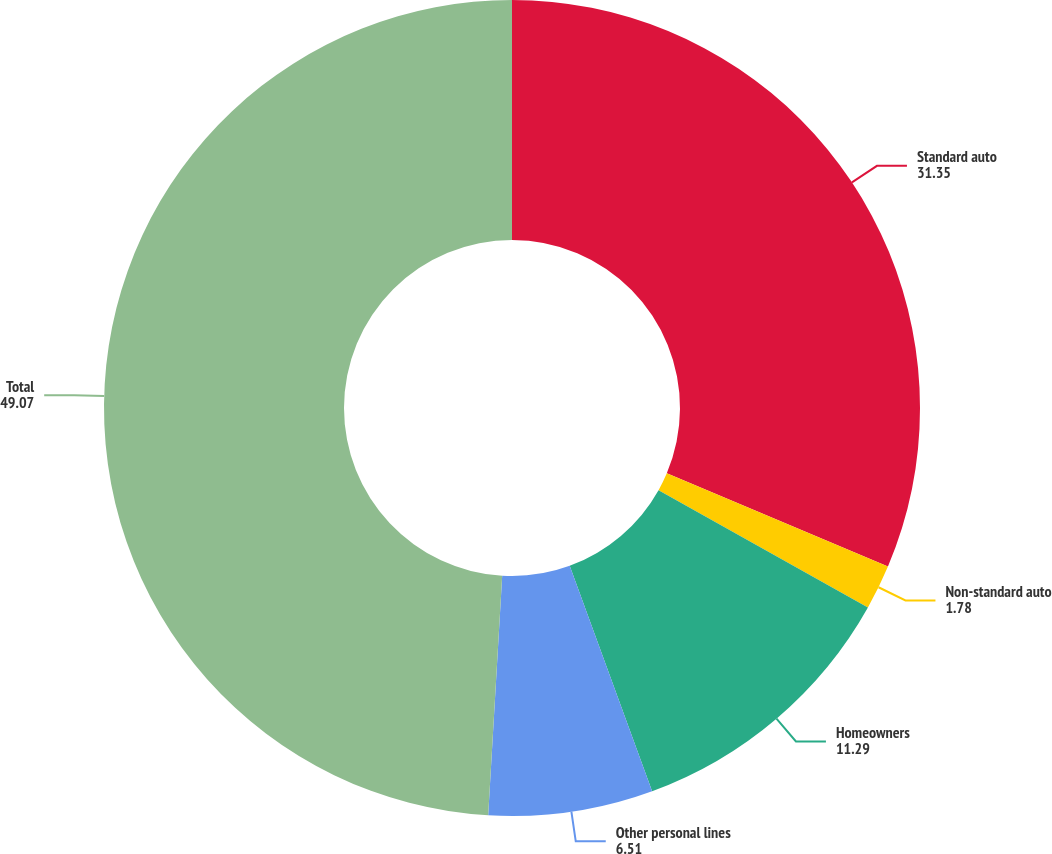Convert chart. <chart><loc_0><loc_0><loc_500><loc_500><pie_chart><fcel>Standard auto<fcel>Non-standard auto<fcel>Homeowners<fcel>Other personal lines<fcel>Total<nl><fcel>31.35%<fcel>1.78%<fcel>11.29%<fcel>6.51%<fcel>49.07%<nl></chart> 